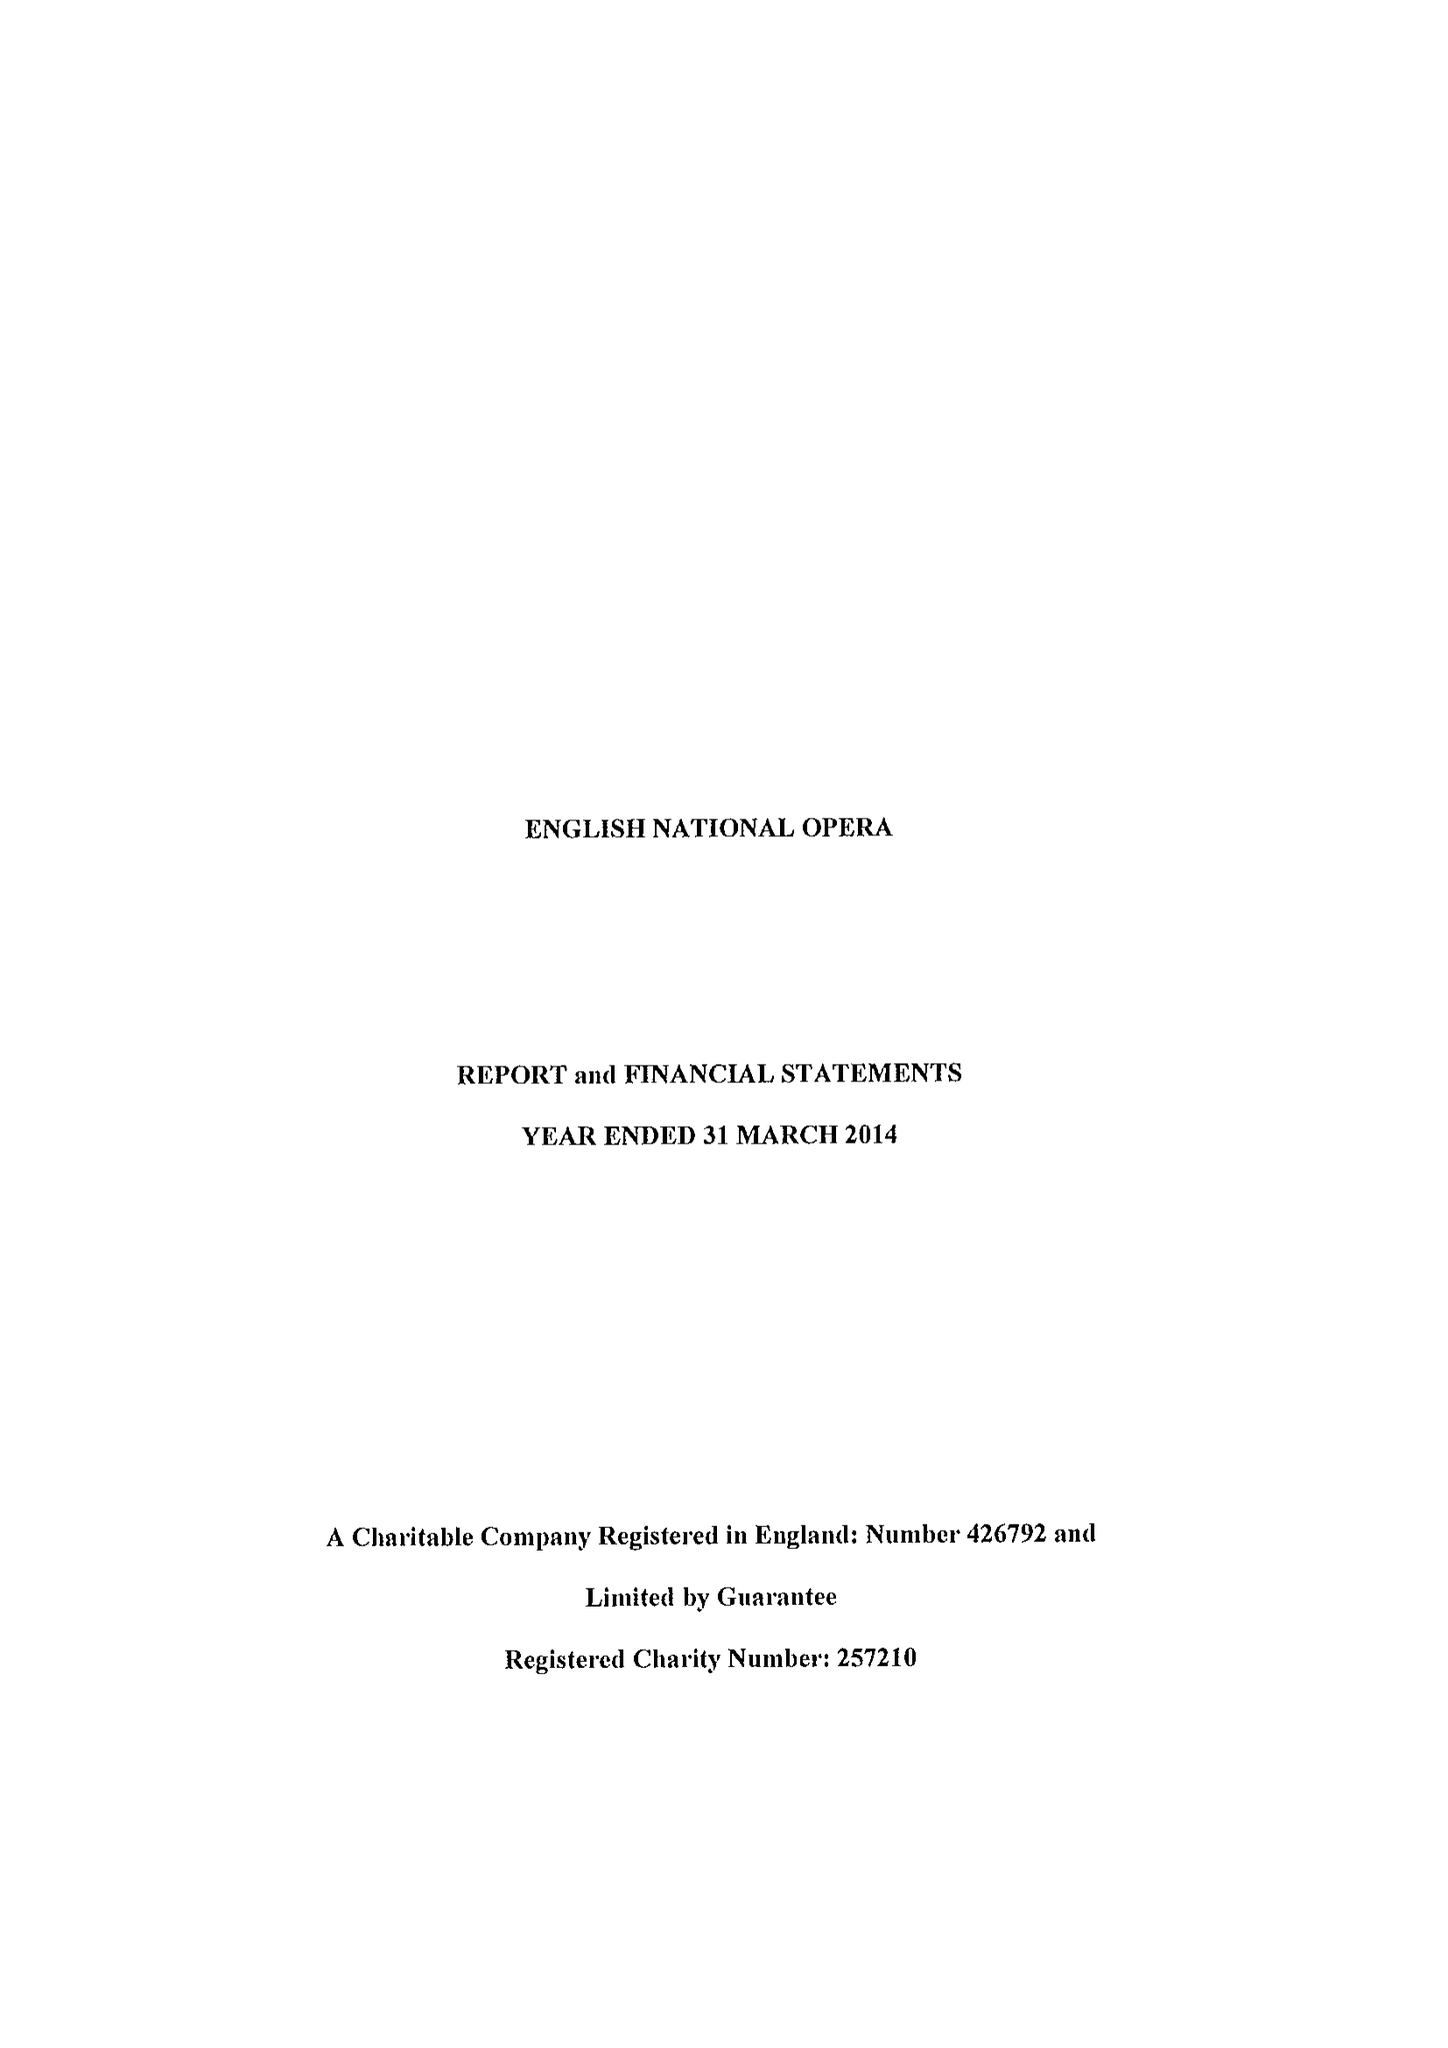What is the value for the address__street_line?
Answer the question using a single word or phrase. ST MARTINS LANE 